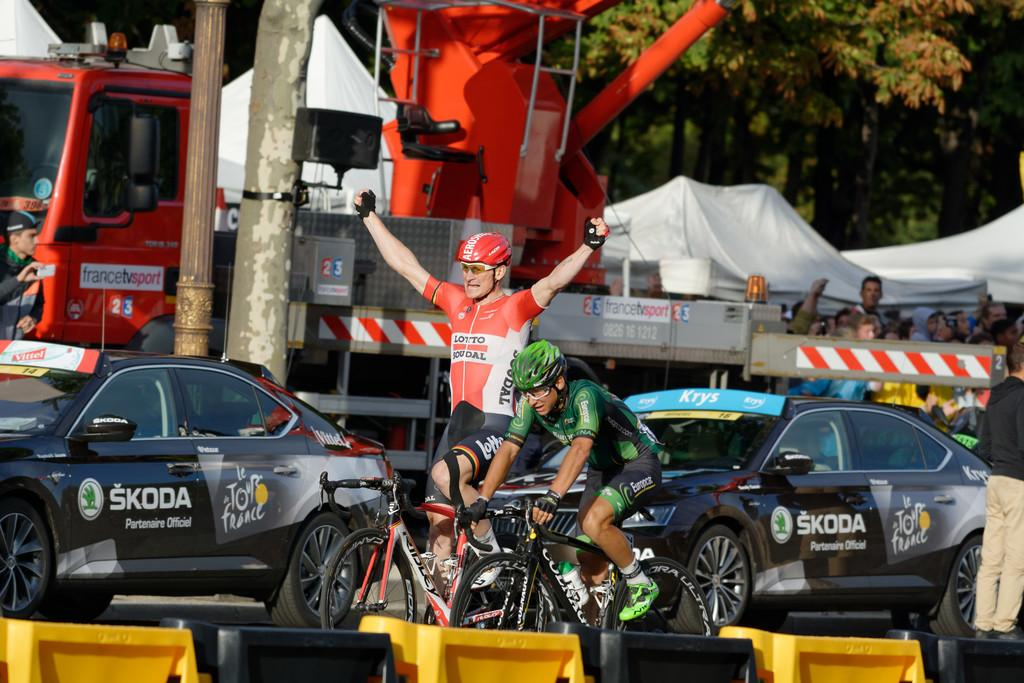Who or what can be seen in the image? There are people in the image. What mode of transportation is present in the image? There are bicycles, cars, and a truck in the image. What type of vegetation is visible in the image? There are trees in the image. What color is the crayon used to draw the word in the image? There is no crayon or word present in the image. 